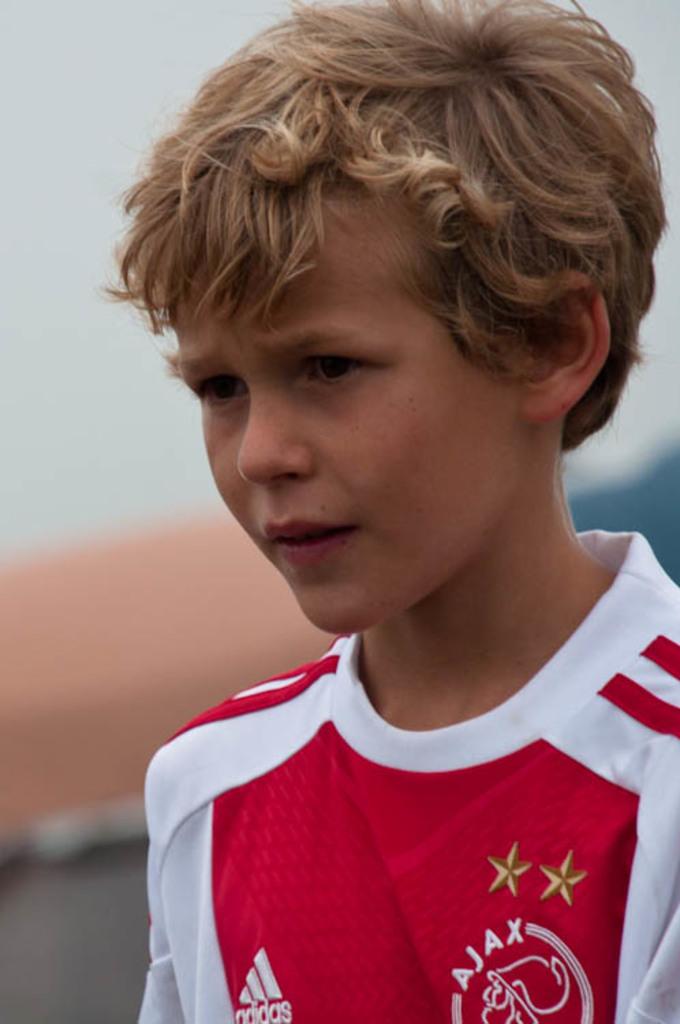What brand is on the jersey?
Your answer should be very brief. Adidas. What team is this jersey?
Your answer should be very brief. Ajax. 